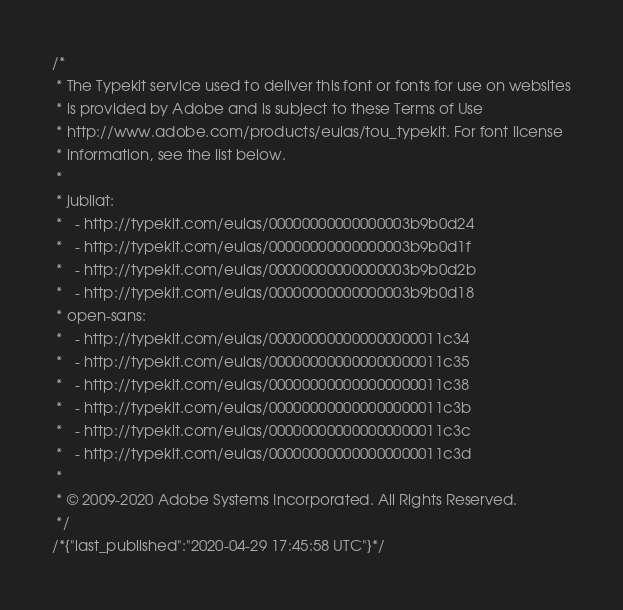Convert code to text. <code><loc_0><loc_0><loc_500><loc_500><_CSS_>/*
 * The Typekit service used to deliver this font or fonts for use on websites
 * is provided by Adobe and is subject to these Terms of Use
 * http://www.adobe.com/products/eulas/tou_typekit. For font license
 * information, see the list below.
 *
 * jubilat:
 *   - http://typekit.com/eulas/00000000000000003b9b0d24
 *   - http://typekit.com/eulas/00000000000000003b9b0d1f
 *   - http://typekit.com/eulas/00000000000000003b9b0d2b
 *   - http://typekit.com/eulas/00000000000000003b9b0d18
 * open-sans:
 *   - http://typekit.com/eulas/000000000000000000011c34
 *   - http://typekit.com/eulas/000000000000000000011c35
 *   - http://typekit.com/eulas/000000000000000000011c38
 *   - http://typekit.com/eulas/000000000000000000011c3b
 *   - http://typekit.com/eulas/000000000000000000011c3c
 *   - http://typekit.com/eulas/000000000000000000011c3d
 *
 * © 2009-2020 Adobe Systems Incorporated. All Rights Reserved.
 */
/*{"last_published":"2020-04-29 17:45:58 UTC"}*/
</code> 